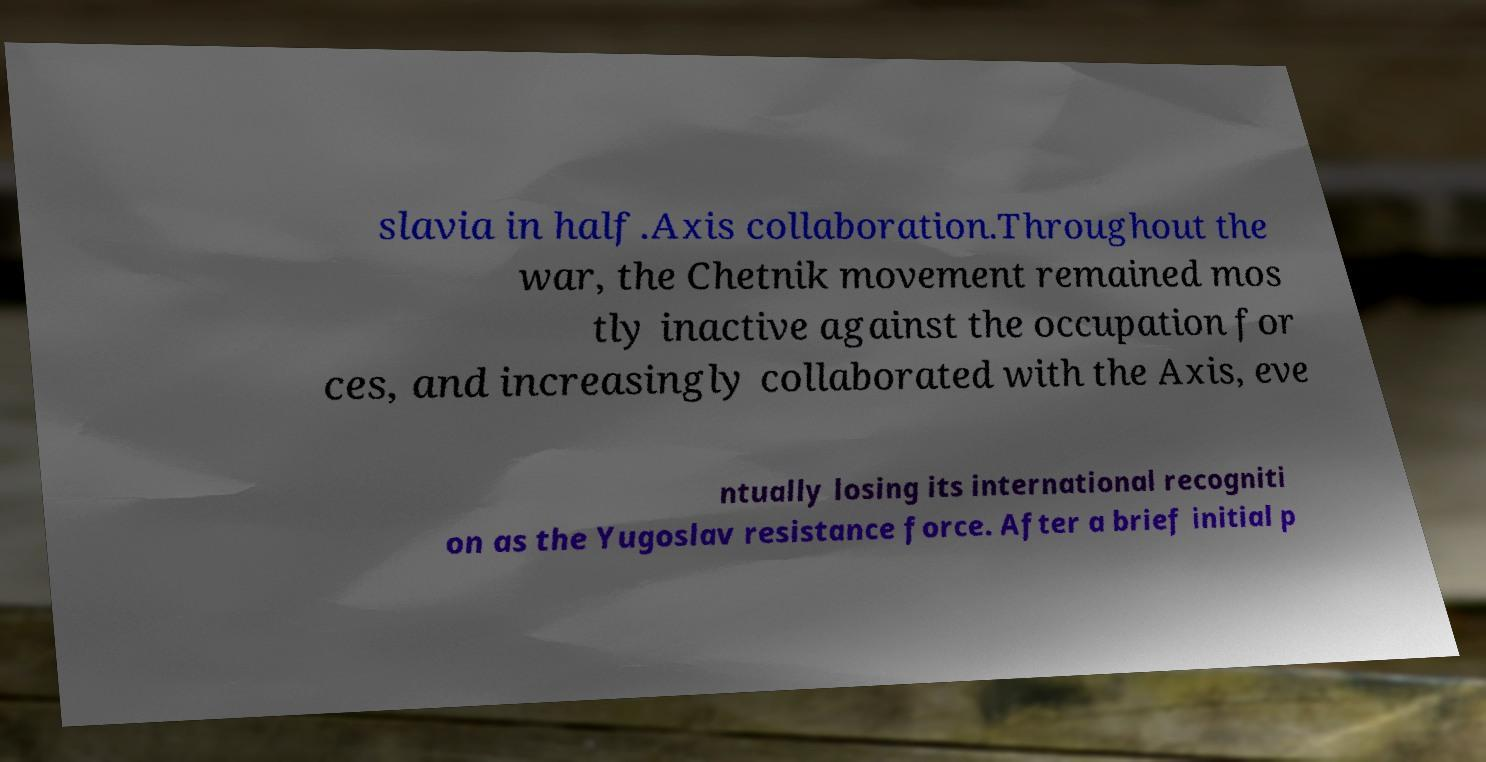What messages or text are displayed in this image? I need them in a readable, typed format. slavia in half.Axis collaboration.Throughout the war, the Chetnik movement remained mos tly inactive against the occupation for ces, and increasingly collaborated with the Axis, eve ntually losing its international recogniti on as the Yugoslav resistance force. After a brief initial p 